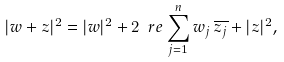Convert formula to latex. <formula><loc_0><loc_0><loc_500><loc_500>| w + z | ^ { 2 } = | w | ^ { 2 } + 2 \ r e \sum _ { j = 1 } ^ { n } w _ { j } \, \overline { z _ { j } } + | z | ^ { 2 } ,</formula> 